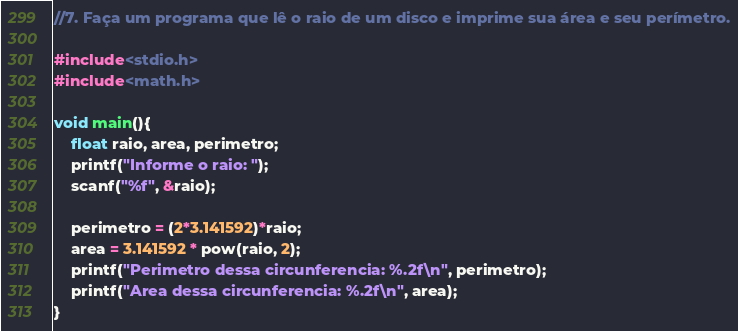Convert code to text. <code><loc_0><loc_0><loc_500><loc_500><_C_>//7. Faça um programa que lê o raio de um disco e imprime sua área e seu perímetro.

#include<stdio.h>
#include<math.h>

void main(){
	float raio, area, perimetro;
	printf("Informe o raio: ");
	scanf("%f", &raio);

	perimetro = (2*3.141592)*raio;
	area = 3.141592 * pow(raio, 2);
	printf("Perimetro dessa circunferencia: %.2f\n", perimetro);
	printf("Area dessa circunferencia: %.2f\n", area);
}
</code> 